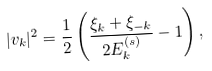<formula> <loc_0><loc_0><loc_500><loc_500>| v _ { k } | ^ { 2 } = \frac { 1 } { 2 } \left ( \frac { \xi _ { k } + \xi _ { - k } } { 2 E ^ { ( s ) } _ { k } } - 1 \right ) ,</formula> 